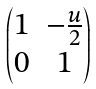<formula> <loc_0><loc_0><loc_500><loc_500>\begin{pmatrix} 1 & - \frac { u } { 2 } \\ 0 & 1 \end{pmatrix}</formula> 